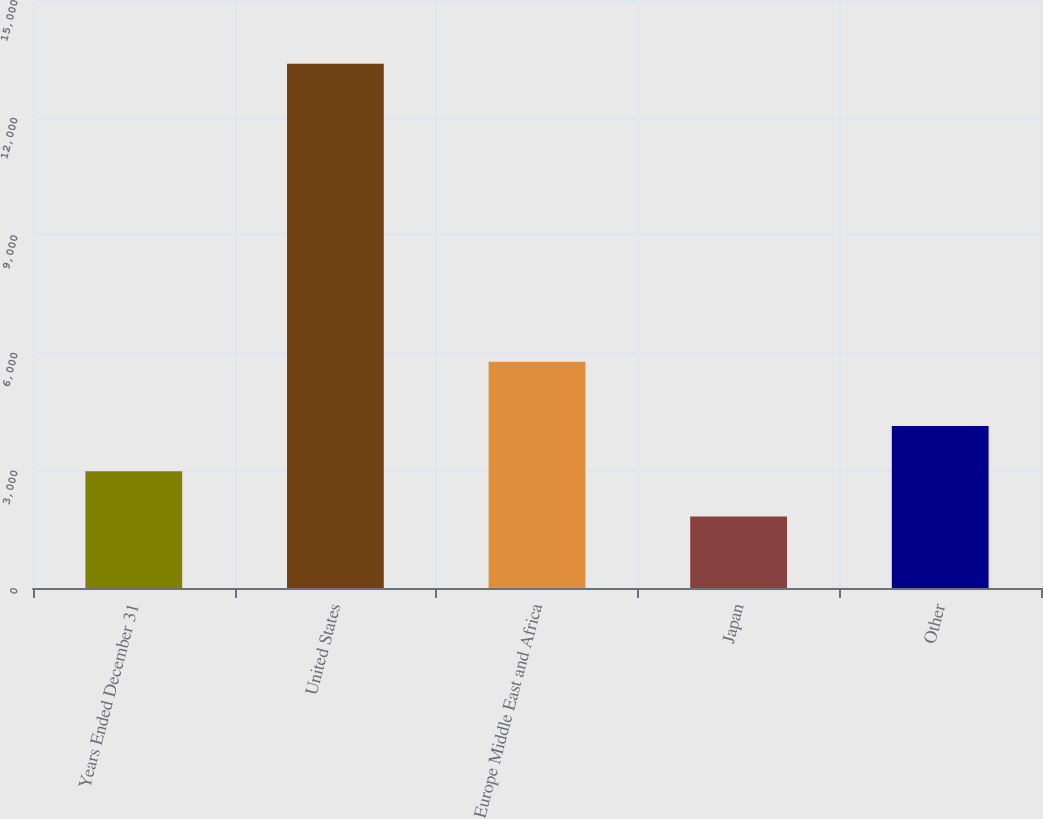<chart> <loc_0><loc_0><loc_500><loc_500><bar_chart><fcel>Years Ended December 31<fcel>United States<fcel>Europe Middle East and Africa<fcel>Japan<fcel>Other<nl><fcel>2977.8<fcel>13371<fcel>5774<fcel>1823<fcel>4132.6<nl></chart> 